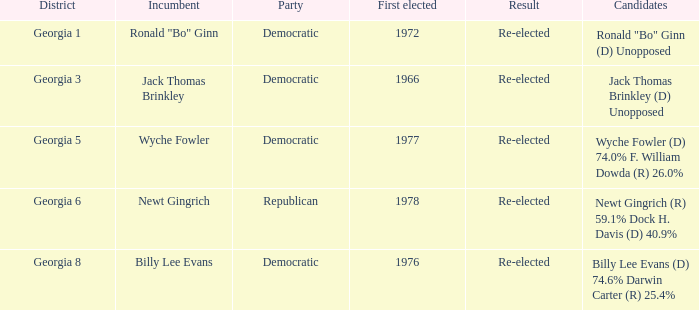What is the event with the nominees newt gingrich (r) 5 Republican. 